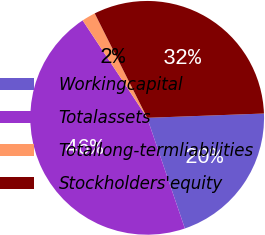Convert chart to OTSL. <chart><loc_0><loc_0><loc_500><loc_500><pie_chart><fcel>Workingcapital<fcel>Totalassets<fcel>Totallong-termliabilities<fcel>Stockholders'equity<nl><fcel>20.36%<fcel>45.92%<fcel>1.9%<fcel>31.82%<nl></chart> 